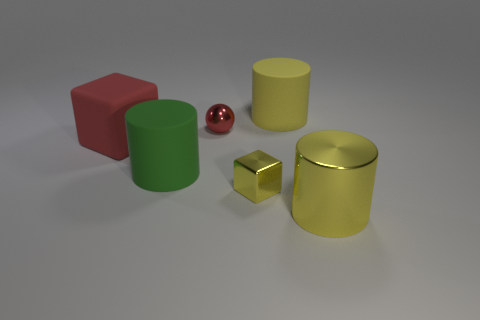Can you tell me which object is the smallest in the image? The smallest object in the image is the shiny red sphere. 